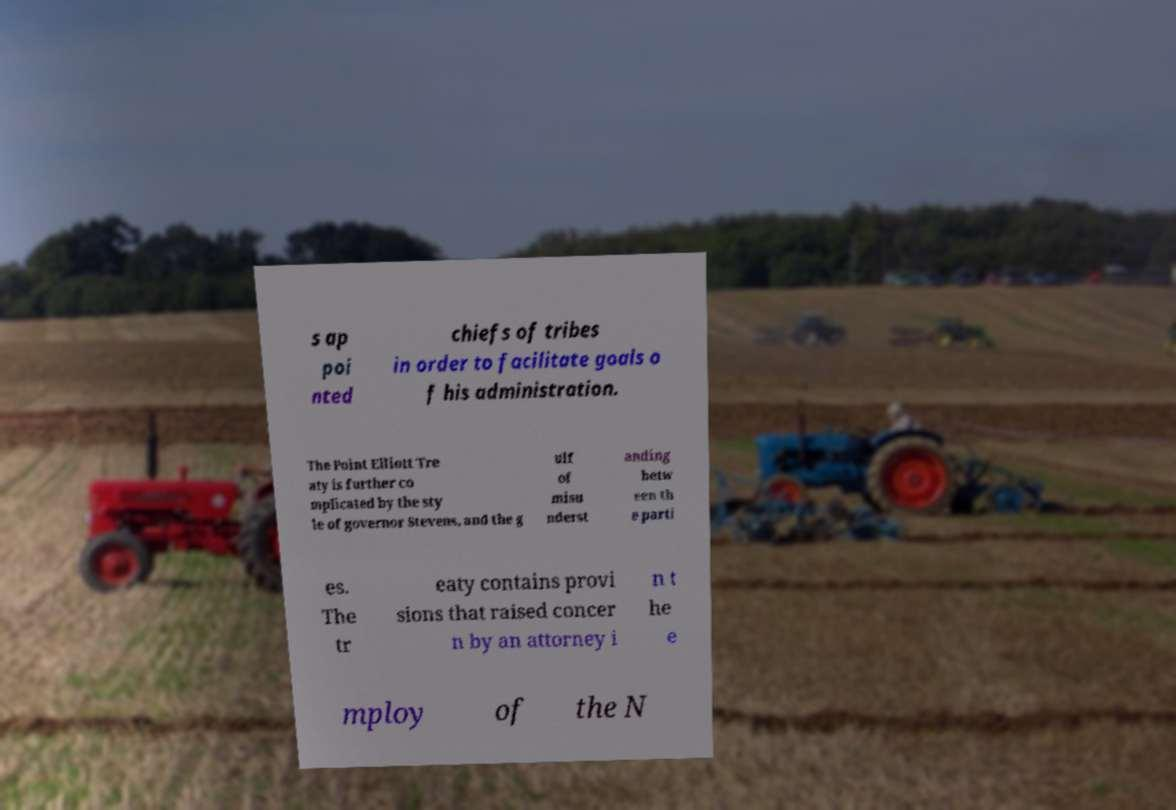Can you read and provide the text displayed in the image?This photo seems to have some interesting text. Can you extract and type it out for me? s ap poi nted chiefs of tribes in order to facilitate goals o f his administration. The Point Elliott Tre aty is further co mplicated by the sty le of governor Stevens, and the g ulf of misu nderst anding betw een th e parti es. The tr eaty contains provi sions that raised concer n by an attorney i n t he e mploy of the N 